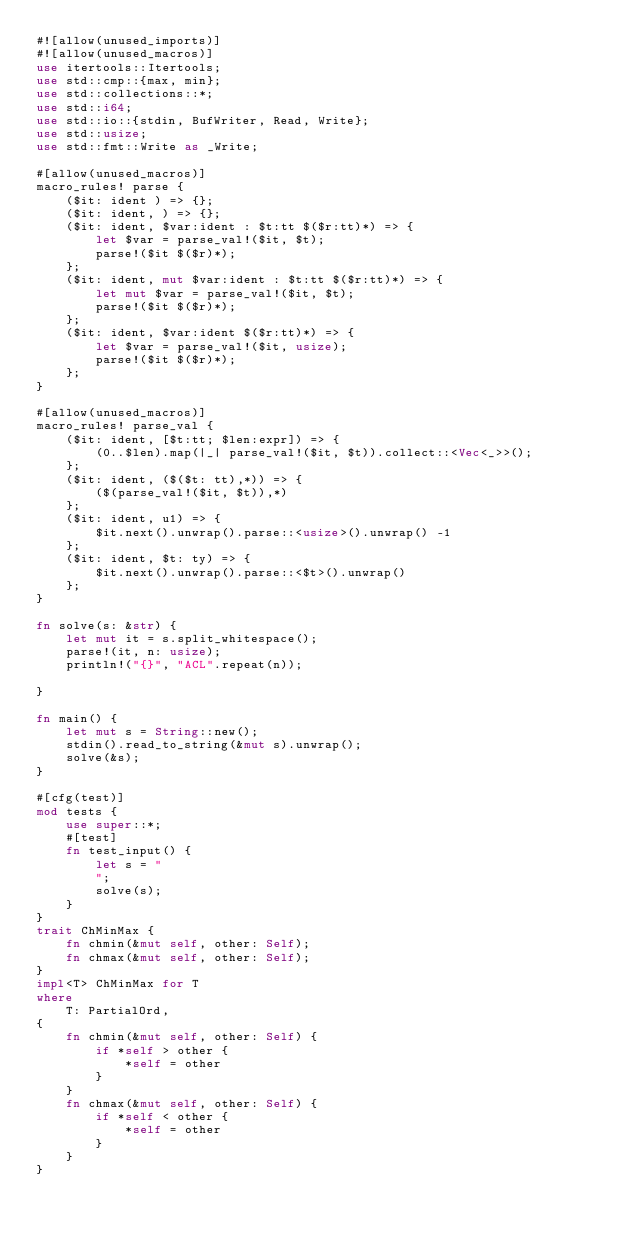Convert code to text. <code><loc_0><loc_0><loc_500><loc_500><_Rust_>#![allow(unused_imports)]
#![allow(unused_macros)]
use itertools::Itertools;
use std::cmp::{max, min};
use std::collections::*;
use std::i64;
use std::io::{stdin, BufWriter, Read, Write};
use std::usize;
use std::fmt::Write as _Write;

#[allow(unused_macros)]
macro_rules! parse {
    ($it: ident ) => {};
    ($it: ident, ) => {};
    ($it: ident, $var:ident : $t:tt $($r:tt)*) => {
        let $var = parse_val!($it, $t);
        parse!($it $($r)*);
    };
    ($it: ident, mut $var:ident : $t:tt $($r:tt)*) => {
        let mut $var = parse_val!($it, $t);
        parse!($it $($r)*);
    };
    ($it: ident, $var:ident $($r:tt)*) => {
        let $var = parse_val!($it, usize);
        parse!($it $($r)*);
    };
}

#[allow(unused_macros)]
macro_rules! parse_val {
    ($it: ident, [$t:tt; $len:expr]) => {
        (0..$len).map(|_| parse_val!($it, $t)).collect::<Vec<_>>();
    };
    ($it: ident, ($($t: tt),*)) => {
        ($(parse_val!($it, $t)),*)
    };
    ($it: ident, u1) => {
        $it.next().unwrap().parse::<usize>().unwrap() -1
    };
    ($it: ident, $t: ty) => {
        $it.next().unwrap().parse::<$t>().unwrap()
    };
}

fn solve(s: &str) {
    let mut it = s.split_whitespace();
    parse!(it, n: usize);
    println!("{}", "ACL".repeat(n));

}

fn main() {
    let mut s = String::new();
    stdin().read_to_string(&mut s).unwrap();
    solve(&s);
}

#[cfg(test)]
mod tests {
    use super::*;
    #[test]
    fn test_input() {
        let s = "
        ";
        solve(s);
    }
}
trait ChMinMax {
    fn chmin(&mut self, other: Self);
    fn chmax(&mut self, other: Self);
}
impl<T> ChMinMax for T
where
    T: PartialOrd,
{
    fn chmin(&mut self, other: Self) {
        if *self > other {
            *self = other
        }
    }
    fn chmax(&mut self, other: Self) {
        if *self < other {
            *self = other
        }
    }
}

</code> 